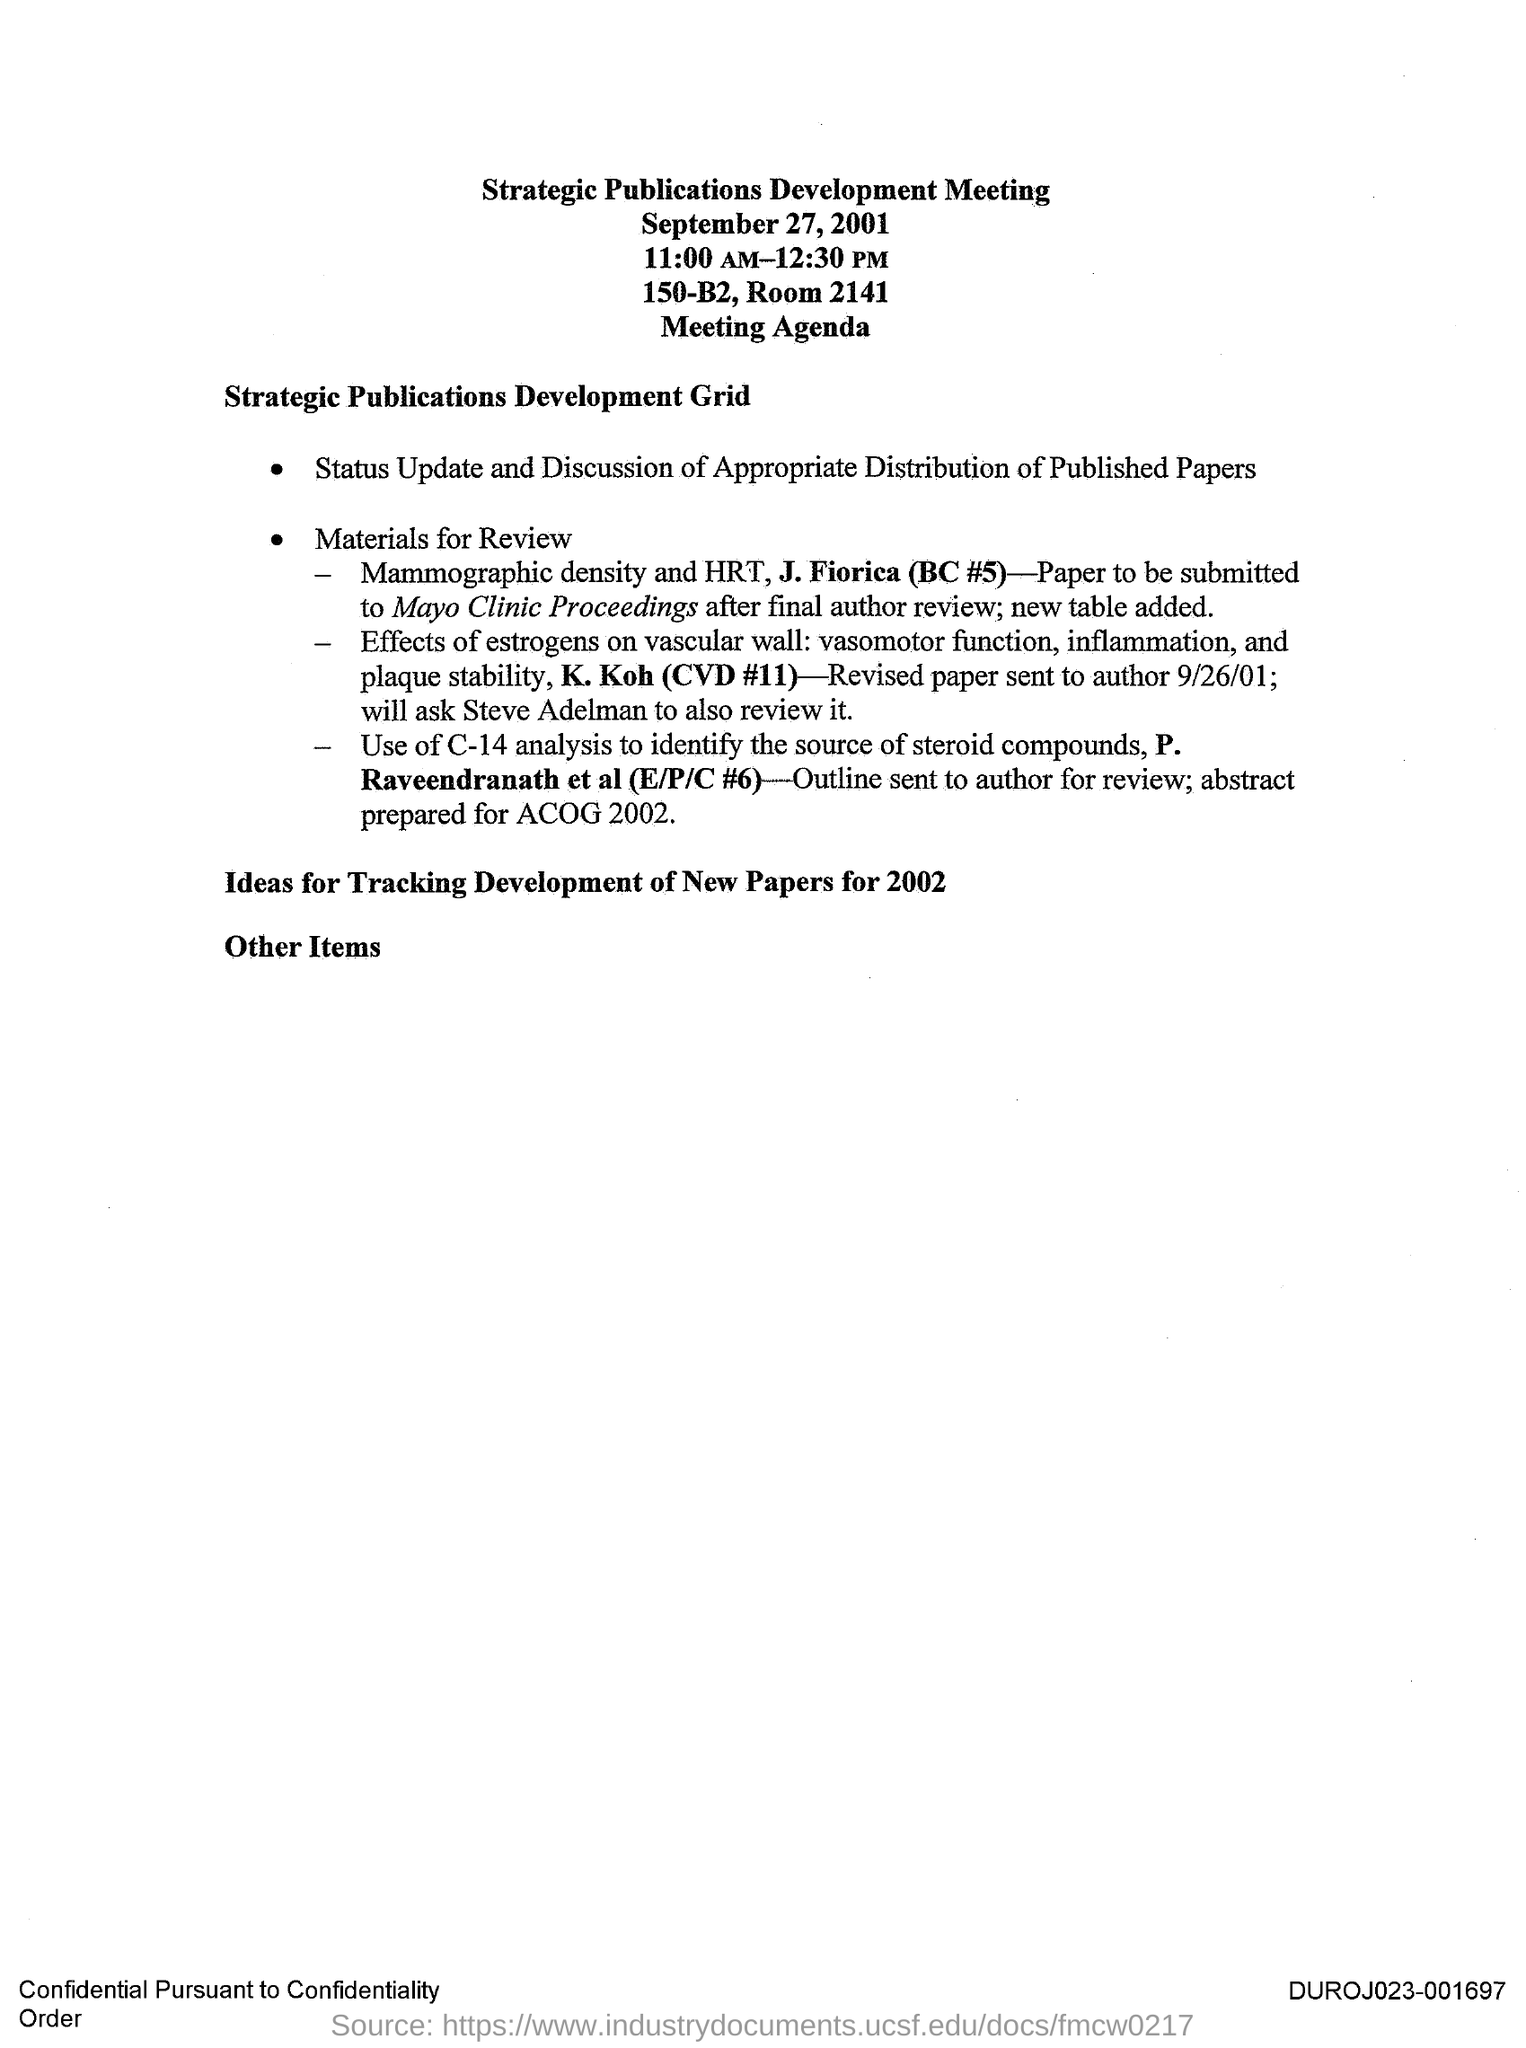When is the Strategic Publications Development Meeting held?
Provide a succinct answer. September 27, 2001. What time is the Strategic Publications Development Meeting held?
Ensure brevity in your answer.  11:00 AM-12:30 PM. Where is the Strategic Publications Development Meeting held?
Make the answer very short. 150-B2, Room 2141. When was the Revised Paper sent to the author?
Your response must be concise. 9/26/01. 